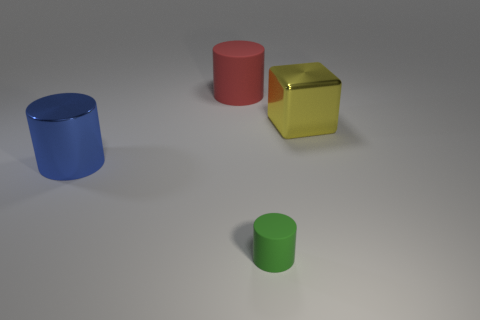Subtract all red cylinders. How many cylinders are left? 2 Add 1 red objects. How many objects exist? 5 Subtract all cubes. How many objects are left? 3 Subtract all yellow cubes. Subtract all small things. How many objects are left? 2 Add 2 matte objects. How many matte objects are left? 4 Add 2 large green rubber things. How many large green rubber things exist? 2 Subtract 0 gray balls. How many objects are left? 4 Subtract all red cylinders. Subtract all gray cubes. How many cylinders are left? 2 